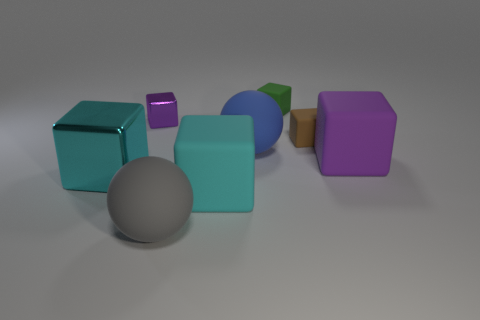The tiny cube on the left side of the large rubber ball on the left side of the matte ball behind the purple rubber block is what color?
Your answer should be very brief. Purple. How many metal things are brown objects or blue spheres?
Offer a terse response. 0. Do the purple metal cube and the gray rubber thing have the same size?
Your response must be concise. No. Are there fewer small brown blocks on the right side of the large blue sphere than metallic cubes that are in front of the small metal thing?
Your answer should be compact. No. What size is the purple metallic block?
Offer a terse response. Small. What number of tiny things are either green blocks or brown matte blocks?
Make the answer very short. 2. There is a blue object; is its size the same as the block that is in front of the big cyan metal cube?
Make the answer very short. Yes. How many small green rubber cubes are there?
Provide a succinct answer. 1. What number of blue things are small metallic things or small matte cubes?
Your response must be concise. 0. Is the material of the tiny thing behind the tiny purple object the same as the tiny purple thing?
Ensure brevity in your answer.  No. 